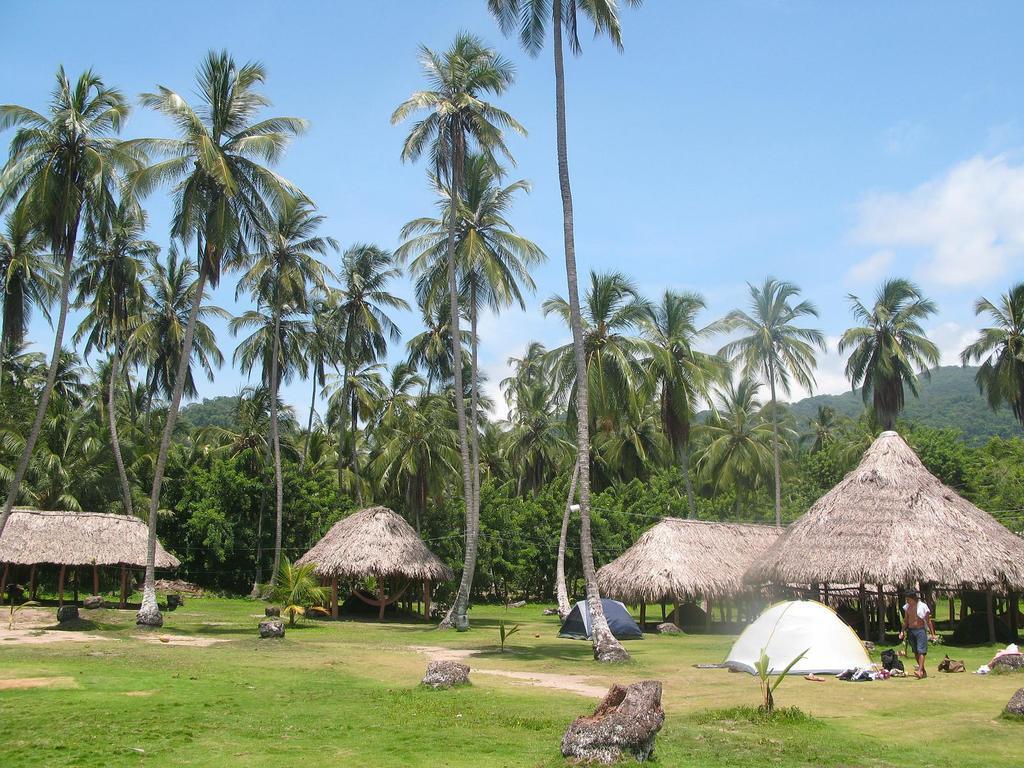Please provide a concise description of this image. In this image we can see a group of huts, trees. To the right side of the image we can see a person standing and two stents placed on the ground. In the background, we can see mountains and the cloudy sky. 